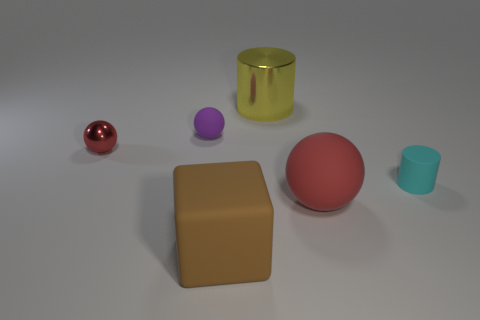Subtract all metallic balls. How many balls are left? 2 Add 3 cylinders. How many objects exist? 9 Subtract all purple spheres. How many spheres are left? 2 Subtract 0 purple cubes. How many objects are left? 6 Subtract all cylinders. How many objects are left? 4 Subtract 2 cylinders. How many cylinders are left? 0 Subtract all brown cylinders. Subtract all blue cubes. How many cylinders are left? 2 Subtract all blue blocks. How many cyan cylinders are left? 1 Subtract all big brown rubber cubes. Subtract all big gray metallic cylinders. How many objects are left? 5 Add 3 red things. How many red things are left? 5 